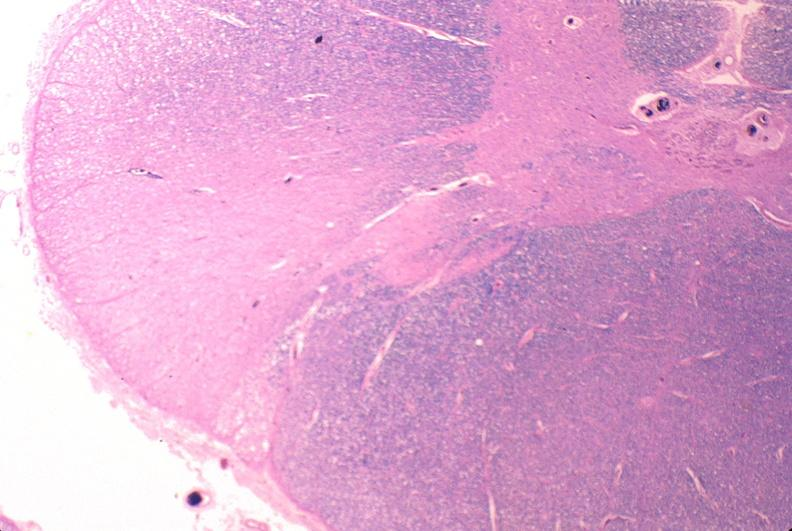what does this image show?
Answer the question using a single word or phrase. Spinal cord injury due to vertebral column trauma 